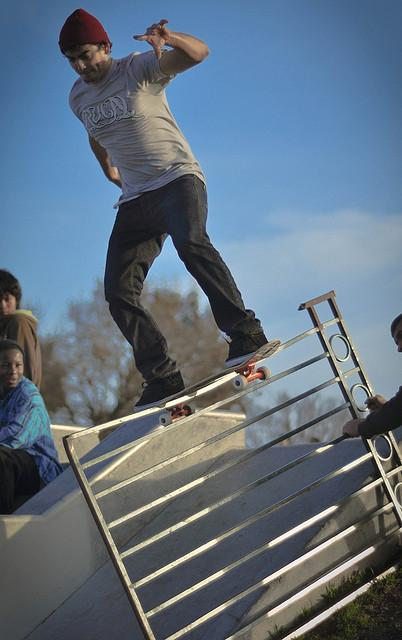Why is the man on top of the railing? Please explain your reasoning. to grind. That's the skateboard move he's doing. 